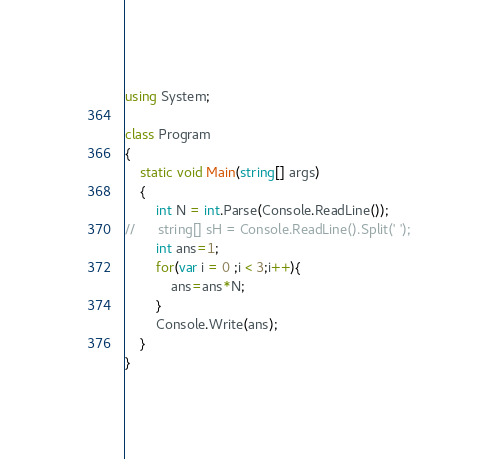Convert code to text. <code><loc_0><loc_0><loc_500><loc_500><_C#_>using System;

class Program
{
	static void Main(string[] args)
	{
		int N = int.Parse(Console.ReadLine());
//		string[] sH = Console.ReadLine().Split(' ');
		int ans=1;
		for(var i = 0 ;i < 3;i++){
			ans=ans*N;
		}
		Console.Write(ans);
	}
}
</code> 